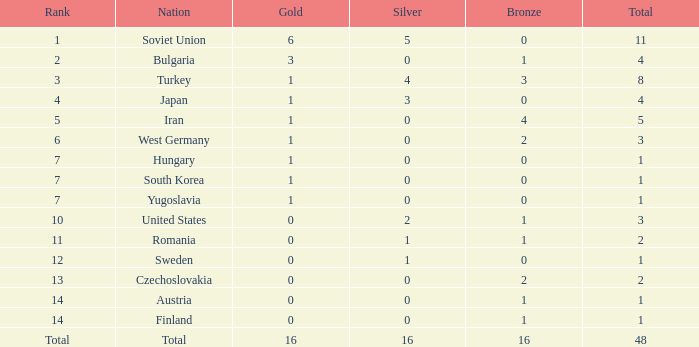How many total golds do teams have when the total medals is less than 1? None. 